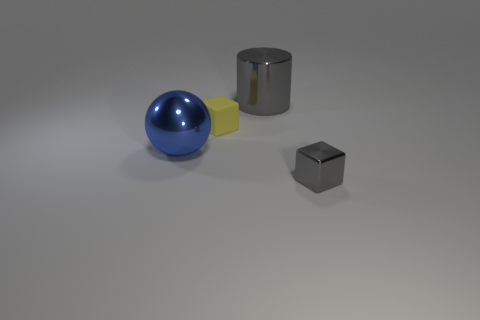Add 4 large green shiny things. How many objects exist? 8 Subtract all cylinders. How many objects are left? 3 Add 4 gray cylinders. How many gray cylinders are left? 5 Add 4 small metallic objects. How many small metallic objects exist? 5 Subtract 0 red cubes. How many objects are left? 4 Subtract all small green balls. Subtract all metallic balls. How many objects are left? 3 